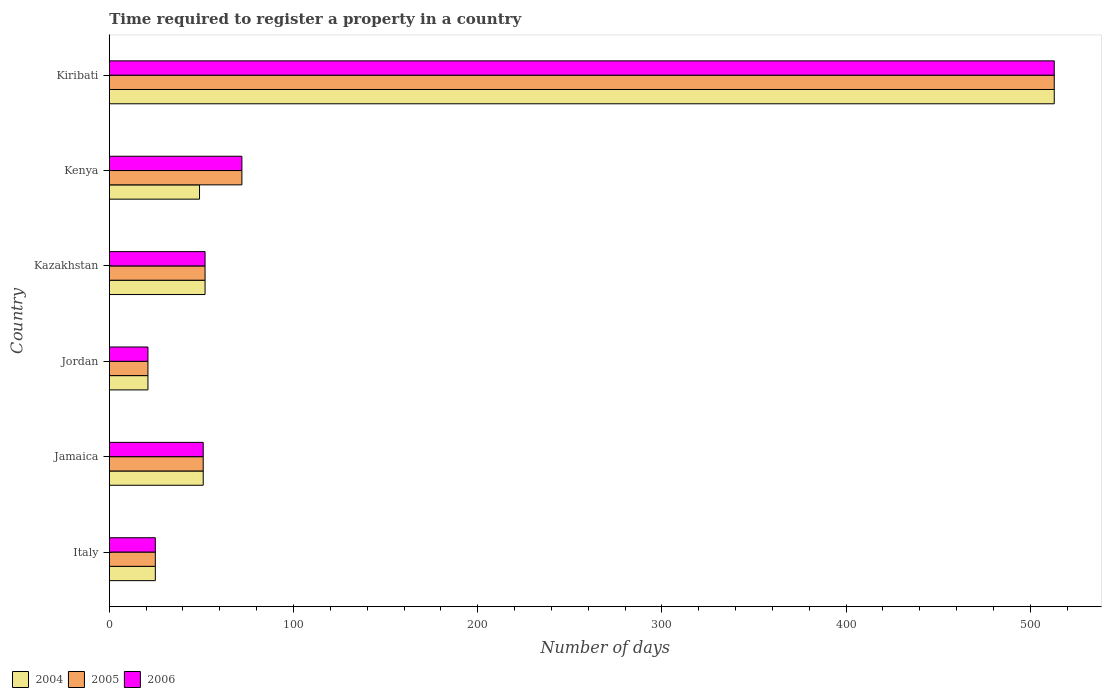How many different coloured bars are there?
Keep it short and to the point. 3. How many groups of bars are there?
Provide a short and direct response. 6. How many bars are there on the 4th tick from the bottom?
Your answer should be compact. 3. What is the label of the 6th group of bars from the top?
Make the answer very short. Italy. What is the number of days required to register a property in 2006 in Kazakhstan?
Offer a very short reply. 52. Across all countries, what is the maximum number of days required to register a property in 2004?
Offer a terse response. 513. Across all countries, what is the minimum number of days required to register a property in 2006?
Your answer should be very brief. 21. In which country was the number of days required to register a property in 2005 maximum?
Ensure brevity in your answer.  Kiribati. In which country was the number of days required to register a property in 2004 minimum?
Offer a very short reply. Jordan. What is the total number of days required to register a property in 2006 in the graph?
Your response must be concise. 734. What is the difference between the number of days required to register a property in 2006 in Jamaica and that in Jordan?
Ensure brevity in your answer.  30. What is the difference between the number of days required to register a property in 2005 in Kiribati and the number of days required to register a property in 2006 in Kenya?
Your response must be concise. 441. What is the average number of days required to register a property in 2006 per country?
Ensure brevity in your answer.  122.33. What is the difference between the number of days required to register a property in 2006 and number of days required to register a property in 2005 in Kiribati?
Give a very brief answer. 0. In how many countries, is the number of days required to register a property in 2005 greater than 360 days?
Your response must be concise. 1. What is the ratio of the number of days required to register a property in 2005 in Kenya to that in Kiribati?
Offer a terse response. 0.14. What is the difference between the highest and the second highest number of days required to register a property in 2005?
Keep it short and to the point. 441. What is the difference between the highest and the lowest number of days required to register a property in 2004?
Provide a succinct answer. 492. In how many countries, is the number of days required to register a property in 2004 greater than the average number of days required to register a property in 2004 taken over all countries?
Your answer should be very brief. 1. Is the sum of the number of days required to register a property in 2005 in Italy and Kenya greater than the maximum number of days required to register a property in 2004 across all countries?
Ensure brevity in your answer.  No. What does the 1st bar from the top in Italy represents?
Provide a short and direct response. 2006. What does the 3rd bar from the bottom in Kiribati represents?
Provide a short and direct response. 2006. How many bars are there?
Your response must be concise. 18. How many countries are there in the graph?
Offer a very short reply. 6. Does the graph contain any zero values?
Provide a succinct answer. No. How many legend labels are there?
Provide a succinct answer. 3. What is the title of the graph?
Keep it short and to the point. Time required to register a property in a country. Does "1982" appear as one of the legend labels in the graph?
Your answer should be compact. No. What is the label or title of the X-axis?
Your answer should be very brief. Number of days. What is the label or title of the Y-axis?
Provide a short and direct response. Country. What is the Number of days of 2005 in Italy?
Your answer should be compact. 25. What is the Number of days of 2006 in Italy?
Give a very brief answer. 25. What is the Number of days of 2004 in Jamaica?
Provide a short and direct response. 51. What is the Number of days in 2005 in Jamaica?
Make the answer very short. 51. What is the Number of days of 2006 in Jamaica?
Keep it short and to the point. 51. What is the Number of days of 2004 in Jordan?
Keep it short and to the point. 21. What is the Number of days in 2006 in Kazakhstan?
Offer a terse response. 52. What is the Number of days of 2006 in Kenya?
Offer a very short reply. 72. What is the Number of days in 2004 in Kiribati?
Ensure brevity in your answer.  513. What is the Number of days of 2005 in Kiribati?
Keep it short and to the point. 513. What is the Number of days of 2006 in Kiribati?
Provide a succinct answer. 513. Across all countries, what is the maximum Number of days of 2004?
Provide a succinct answer. 513. Across all countries, what is the maximum Number of days in 2005?
Offer a terse response. 513. Across all countries, what is the maximum Number of days of 2006?
Provide a short and direct response. 513. Across all countries, what is the minimum Number of days of 2005?
Keep it short and to the point. 21. What is the total Number of days of 2004 in the graph?
Provide a short and direct response. 711. What is the total Number of days of 2005 in the graph?
Offer a terse response. 734. What is the total Number of days of 2006 in the graph?
Provide a short and direct response. 734. What is the difference between the Number of days in 2004 in Italy and that in Jamaica?
Your answer should be compact. -26. What is the difference between the Number of days in 2005 in Italy and that in Jamaica?
Ensure brevity in your answer.  -26. What is the difference between the Number of days in 2006 in Italy and that in Jamaica?
Your answer should be very brief. -26. What is the difference between the Number of days of 2005 in Italy and that in Kazakhstan?
Ensure brevity in your answer.  -27. What is the difference between the Number of days in 2006 in Italy and that in Kazakhstan?
Provide a succinct answer. -27. What is the difference between the Number of days in 2005 in Italy and that in Kenya?
Your response must be concise. -47. What is the difference between the Number of days in 2006 in Italy and that in Kenya?
Keep it short and to the point. -47. What is the difference between the Number of days of 2004 in Italy and that in Kiribati?
Keep it short and to the point. -488. What is the difference between the Number of days of 2005 in Italy and that in Kiribati?
Offer a terse response. -488. What is the difference between the Number of days in 2006 in Italy and that in Kiribati?
Provide a short and direct response. -488. What is the difference between the Number of days of 2004 in Jamaica and that in Kazakhstan?
Make the answer very short. -1. What is the difference between the Number of days in 2005 in Jamaica and that in Kazakhstan?
Give a very brief answer. -1. What is the difference between the Number of days in 2005 in Jamaica and that in Kenya?
Your answer should be compact. -21. What is the difference between the Number of days in 2006 in Jamaica and that in Kenya?
Offer a very short reply. -21. What is the difference between the Number of days in 2004 in Jamaica and that in Kiribati?
Your response must be concise. -462. What is the difference between the Number of days in 2005 in Jamaica and that in Kiribati?
Ensure brevity in your answer.  -462. What is the difference between the Number of days in 2006 in Jamaica and that in Kiribati?
Your answer should be very brief. -462. What is the difference between the Number of days in 2004 in Jordan and that in Kazakhstan?
Offer a very short reply. -31. What is the difference between the Number of days of 2005 in Jordan and that in Kazakhstan?
Make the answer very short. -31. What is the difference between the Number of days in 2006 in Jordan and that in Kazakhstan?
Your answer should be very brief. -31. What is the difference between the Number of days in 2005 in Jordan and that in Kenya?
Your answer should be compact. -51. What is the difference between the Number of days of 2006 in Jordan and that in Kenya?
Offer a very short reply. -51. What is the difference between the Number of days in 2004 in Jordan and that in Kiribati?
Offer a terse response. -492. What is the difference between the Number of days in 2005 in Jordan and that in Kiribati?
Offer a very short reply. -492. What is the difference between the Number of days in 2006 in Jordan and that in Kiribati?
Offer a very short reply. -492. What is the difference between the Number of days in 2004 in Kazakhstan and that in Kenya?
Provide a succinct answer. 3. What is the difference between the Number of days of 2004 in Kazakhstan and that in Kiribati?
Give a very brief answer. -461. What is the difference between the Number of days in 2005 in Kazakhstan and that in Kiribati?
Provide a short and direct response. -461. What is the difference between the Number of days of 2006 in Kazakhstan and that in Kiribati?
Offer a terse response. -461. What is the difference between the Number of days in 2004 in Kenya and that in Kiribati?
Provide a short and direct response. -464. What is the difference between the Number of days of 2005 in Kenya and that in Kiribati?
Provide a succinct answer. -441. What is the difference between the Number of days of 2006 in Kenya and that in Kiribati?
Give a very brief answer. -441. What is the difference between the Number of days in 2005 in Italy and the Number of days in 2006 in Jamaica?
Give a very brief answer. -26. What is the difference between the Number of days in 2004 in Italy and the Number of days in 2005 in Kazakhstan?
Provide a succinct answer. -27. What is the difference between the Number of days of 2004 in Italy and the Number of days of 2005 in Kenya?
Ensure brevity in your answer.  -47. What is the difference between the Number of days of 2004 in Italy and the Number of days of 2006 in Kenya?
Provide a succinct answer. -47. What is the difference between the Number of days of 2005 in Italy and the Number of days of 2006 in Kenya?
Provide a succinct answer. -47. What is the difference between the Number of days in 2004 in Italy and the Number of days in 2005 in Kiribati?
Keep it short and to the point. -488. What is the difference between the Number of days in 2004 in Italy and the Number of days in 2006 in Kiribati?
Offer a very short reply. -488. What is the difference between the Number of days in 2005 in Italy and the Number of days in 2006 in Kiribati?
Your answer should be compact. -488. What is the difference between the Number of days in 2004 in Jamaica and the Number of days in 2005 in Jordan?
Provide a succinct answer. 30. What is the difference between the Number of days of 2004 in Jamaica and the Number of days of 2006 in Jordan?
Give a very brief answer. 30. What is the difference between the Number of days in 2004 in Jamaica and the Number of days in 2005 in Kazakhstan?
Your answer should be very brief. -1. What is the difference between the Number of days in 2004 in Jamaica and the Number of days in 2005 in Kenya?
Give a very brief answer. -21. What is the difference between the Number of days in 2004 in Jamaica and the Number of days in 2006 in Kenya?
Ensure brevity in your answer.  -21. What is the difference between the Number of days of 2005 in Jamaica and the Number of days of 2006 in Kenya?
Make the answer very short. -21. What is the difference between the Number of days in 2004 in Jamaica and the Number of days in 2005 in Kiribati?
Your response must be concise. -462. What is the difference between the Number of days in 2004 in Jamaica and the Number of days in 2006 in Kiribati?
Give a very brief answer. -462. What is the difference between the Number of days in 2005 in Jamaica and the Number of days in 2006 in Kiribati?
Make the answer very short. -462. What is the difference between the Number of days in 2004 in Jordan and the Number of days in 2005 in Kazakhstan?
Provide a succinct answer. -31. What is the difference between the Number of days of 2004 in Jordan and the Number of days of 2006 in Kazakhstan?
Your response must be concise. -31. What is the difference between the Number of days of 2005 in Jordan and the Number of days of 2006 in Kazakhstan?
Ensure brevity in your answer.  -31. What is the difference between the Number of days in 2004 in Jordan and the Number of days in 2005 in Kenya?
Provide a short and direct response. -51. What is the difference between the Number of days of 2004 in Jordan and the Number of days of 2006 in Kenya?
Your answer should be very brief. -51. What is the difference between the Number of days of 2005 in Jordan and the Number of days of 2006 in Kenya?
Ensure brevity in your answer.  -51. What is the difference between the Number of days in 2004 in Jordan and the Number of days in 2005 in Kiribati?
Your answer should be compact. -492. What is the difference between the Number of days in 2004 in Jordan and the Number of days in 2006 in Kiribati?
Ensure brevity in your answer.  -492. What is the difference between the Number of days of 2005 in Jordan and the Number of days of 2006 in Kiribati?
Your answer should be compact. -492. What is the difference between the Number of days of 2004 in Kazakhstan and the Number of days of 2005 in Kenya?
Offer a very short reply. -20. What is the difference between the Number of days of 2005 in Kazakhstan and the Number of days of 2006 in Kenya?
Offer a terse response. -20. What is the difference between the Number of days in 2004 in Kazakhstan and the Number of days in 2005 in Kiribati?
Your answer should be very brief. -461. What is the difference between the Number of days in 2004 in Kazakhstan and the Number of days in 2006 in Kiribati?
Offer a very short reply. -461. What is the difference between the Number of days of 2005 in Kazakhstan and the Number of days of 2006 in Kiribati?
Keep it short and to the point. -461. What is the difference between the Number of days of 2004 in Kenya and the Number of days of 2005 in Kiribati?
Your response must be concise. -464. What is the difference between the Number of days in 2004 in Kenya and the Number of days in 2006 in Kiribati?
Your response must be concise. -464. What is the difference between the Number of days of 2005 in Kenya and the Number of days of 2006 in Kiribati?
Give a very brief answer. -441. What is the average Number of days of 2004 per country?
Ensure brevity in your answer.  118.5. What is the average Number of days of 2005 per country?
Give a very brief answer. 122.33. What is the average Number of days in 2006 per country?
Offer a terse response. 122.33. What is the difference between the Number of days of 2004 and Number of days of 2005 in Italy?
Make the answer very short. 0. What is the difference between the Number of days of 2004 and Number of days of 2006 in Italy?
Offer a terse response. 0. What is the difference between the Number of days of 2005 and Number of days of 2006 in Italy?
Your response must be concise. 0. What is the difference between the Number of days in 2005 and Number of days in 2006 in Jamaica?
Give a very brief answer. 0. What is the difference between the Number of days of 2004 and Number of days of 2005 in Kazakhstan?
Give a very brief answer. 0. What is the difference between the Number of days in 2004 and Number of days in 2006 in Kazakhstan?
Offer a very short reply. 0. What is the difference between the Number of days in 2005 and Number of days in 2006 in Kazakhstan?
Provide a short and direct response. 0. What is the difference between the Number of days of 2004 and Number of days of 2006 in Kenya?
Keep it short and to the point. -23. What is the difference between the Number of days in 2004 and Number of days in 2005 in Kiribati?
Keep it short and to the point. 0. What is the difference between the Number of days of 2005 and Number of days of 2006 in Kiribati?
Your response must be concise. 0. What is the ratio of the Number of days in 2004 in Italy to that in Jamaica?
Ensure brevity in your answer.  0.49. What is the ratio of the Number of days in 2005 in Italy to that in Jamaica?
Offer a very short reply. 0.49. What is the ratio of the Number of days of 2006 in Italy to that in Jamaica?
Offer a very short reply. 0.49. What is the ratio of the Number of days of 2004 in Italy to that in Jordan?
Keep it short and to the point. 1.19. What is the ratio of the Number of days in 2005 in Italy to that in Jordan?
Keep it short and to the point. 1.19. What is the ratio of the Number of days of 2006 in Italy to that in Jordan?
Offer a terse response. 1.19. What is the ratio of the Number of days of 2004 in Italy to that in Kazakhstan?
Make the answer very short. 0.48. What is the ratio of the Number of days of 2005 in Italy to that in Kazakhstan?
Your response must be concise. 0.48. What is the ratio of the Number of days of 2006 in Italy to that in Kazakhstan?
Provide a succinct answer. 0.48. What is the ratio of the Number of days of 2004 in Italy to that in Kenya?
Keep it short and to the point. 0.51. What is the ratio of the Number of days in 2005 in Italy to that in Kenya?
Your answer should be compact. 0.35. What is the ratio of the Number of days of 2006 in Italy to that in Kenya?
Provide a short and direct response. 0.35. What is the ratio of the Number of days in 2004 in Italy to that in Kiribati?
Ensure brevity in your answer.  0.05. What is the ratio of the Number of days in 2005 in Italy to that in Kiribati?
Your response must be concise. 0.05. What is the ratio of the Number of days in 2006 in Italy to that in Kiribati?
Provide a short and direct response. 0.05. What is the ratio of the Number of days of 2004 in Jamaica to that in Jordan?
Offer a very short reply. 2.43. What is the ratio of the Number of days in 2005 in Jamaica to that in Jordan?
Your response must be concise. 2.43. What is the ratio of the Number of days of 2006 in Jamaica to that in Jordan?
Give a very brief answer. 2.43. What is the ratio of the Number of days in 2004 in Jamaica to that in Kazakhstan?
Offer a very short reply. 0.98. What is the ratio of the Number of days in 2005 in Jamaica to that in Kazakhstan?
Make the answer very short. 0.98. What is the ratio of the Number of days in 2006 in Jamaica to that in Kazakhstan?
Give a very brief answer. 0.98. What is the ratio of the Number of days in 2004 in Jamaica to that in Kenya?
Your response must be concise. 1.04. What is the ratio of the Number of days in 2005 in Jamaica to that in Kenya?
Make the answer very short. 0.71. What is the ratio of the Number of days in 2006 in Jamaica to that in Kenya?
Offer a terse response. 0.71. What is the ratio of the Number of days in 2004 in Jamaica to that in Kiribati?
Make the answer very short. 0.1. What is the ratio of the Number of days of 2005 in Jamaica to that in Kiribati?
Give a very brief answer. 0.1. What is the ratio of the Number of days of 2006 in Jamaica to that in Kiribati?
Your answer should be very brief. 0.1. What is the ratio of the Number of days of 2004 in Jordan to that in Kazakhstan?
Ensure brevity in your answer.  0.4. What is the ratio of the Number of days of 2005 in Jordan to that in Kazakhstan?
Ensure brevity in your answer.  0.4. What is the ratio of the Number of days in 2006 in Jordan to that in Kazakhstan?
Ensure brevity in your answer.  0.4. What is the ratio of the Number of days in 2004 in Jordan to that in Kenya?
Offer a terse response. 0.43. What is the ratio of the Number of days of 2005 in Jordan to that in Kenya?
Make the answer very short. 0.29. What is the ratio of the Number of days in 2006 in Jordan to that in Kenya?
Offer a terse response. 0.29. What is the ratio of the Number of days in 2004 in Jordan to that in Kiribati?
Offer a very short reply. 0.04. What is the ratio of the Number of days of 2005 in Jordan to that in Kiribati?
Offer a terse response. 0.04. What is the ratio of the Number of days of 2006 in Jordan to that in Kiribati?
Provide a short and direct response. 0.04. What is the ratio of the Number of days of 2004 in Kazakhstan to that in Kenya?
Make the answer very short. 1.06. What is the ratio of the Number of days in 2005 in Kazakhstan to that in Kenya?
Offer a terse response. 0.72. What is the ratio of the Number of days in 2006 in Kazakhstan to that in Kenya?
Your answer should be very brief. 0.72. What is the ratio of the Number of days in 2004 in Kazakhstan to that in Kiribati?
Provide a short and direct response. 0.1. What is the ratio of the Number of days in 2005 in Kazakhstan to that in Kiribati?
Your answer should be very brief. 0.1. What is the ratio of the Number of days in 2006 in Kazakhstan to that in Kiribati?
Your answer should be very brief. 0.1. What is the ratio of the Number of days in 2004 in Kenya to that in Kiribati?
Ensure brevity in your answer.  0.1. What is the ratio of the Number of days of 2005 in Kenya to that in Kiribati?
Your answer should be very brief. 0.14. What is the ratio of the Number of days in 2006 in Kenya to that in Kiribati?
Provide a short and direct response. 0.14. What is the difference between the highest and the second highest Number of days in 2004?
Provide a succinct answer. 461. What is the difference between the highest and the second highest Number of days in 2005?
Your response must be concise. 441. What is the difference between the highest and the second highest Number of days of 2006?
Offer a very short reply. 441. What is the difference between the highest and the lowest Number of days of 2004?
Make the answer very short. 492. What is the difference between the highest and the lowest Number of days in 2005?
Your answer should be very brief. 492. What is the difference between the highest and the lowest Number of days of 2006?
Your answer should be compact. 492. 